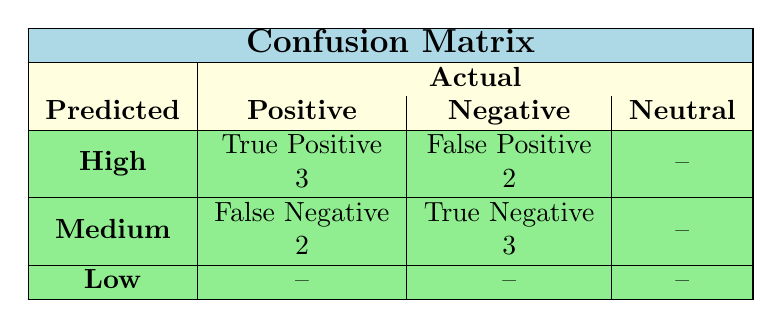What is the number of True Positives for High engagement in Positive sentiment? The table shows that under the Predicted "High" engagement and Actual "Positive," the True Positive count is 3.
Answer: 3 How many False Positives are recorded for Negative sentiment at High engagement? Referring to the table, under the Predicted "High" engagement and Actual "Negative," the False Positive count is 2.
Answer: 2 What is the total number of Medium engagement predictions across all sentiments? From the table, only the Medium engagement is present in the second row, which indicates 2 False Negatives and 3 True Negatives, so the total count is 5.
Answer: 5 Is there any True Positive recorded for Neutral sentiment at High engagement? The table indicates that for Predicted High engagement and Actual Neutral sentiment, there are no True Positives recorded, as it shows a dash for Neutral.
Answer: No What is the sum of True Positives for all sentiments? From the table, True Positives for Positive is 3, for Negative is 2, and for Neutral is 1. Thus, the sum is 3 + 2 + 1 = 6.
Answer: 6 Does the data show that there are more True Positives for High engagement than for Medium engagement? The True Positives for High engagement (3) exceed the False Negatives for Medium engagement (2) but do not directly compare the two since they represent different classifications. Hence, the comparison cannot be made directly based on this information.
Answer: No How many categories have at least one True Positive? The table shows True Positives for Positive (3), Negative (2), and Neutral (1). All three categories have at least one True Positive, totaling three categories.
Answer: 3 What can be concluded about the effectiveness of High engagement in predicting Positive sentiment? The table reveals that High engagement has a True Positive count of 3 and False Positive count of 2 for Positive sentiment, indicating that High engagement is a reasonably effective predictor for Positive sentiment, but it also misclassifies some instances as High when they are not.
Answer: Reasonably effective How many total predictions were made for Low engagement? The table shows that the Low engagement row is marked with dashes for True Positives and other metrics, indicating that no predictions were made (neither True nor False).
Answer: 0 What do the numbers indicate about the relationship between Medium engagement and Negative sentiment? The table shows 2 False Negatives and 3 True Negatives for Medium engagement and Negative sentiment. This indicates that while Medium engagement misses some Negative sentiments, it effectively identifies several others, reflecting a balanced classification.
Answer: Balanced classification 